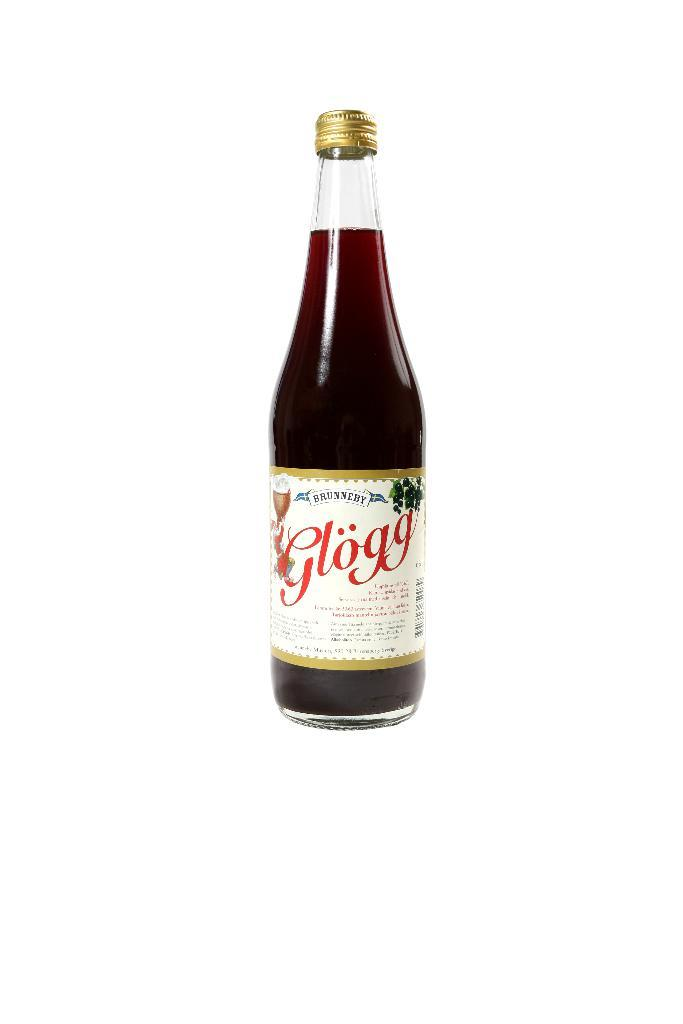Provide a one-sentence caption for the provided image. bottle of brunneby glogg and it has a twist off cap. 